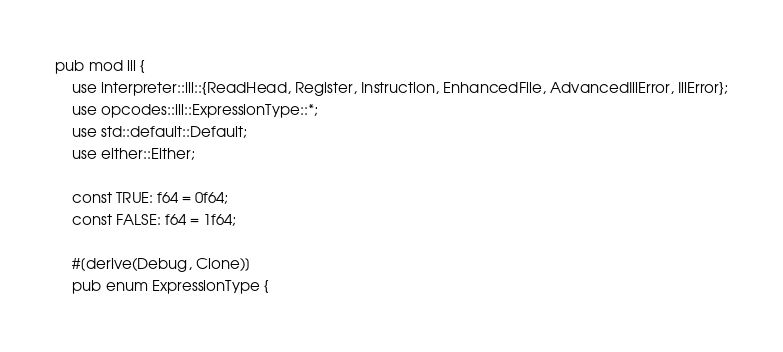<code> <loc_0><loc_0><loc_500><loc_500><_Rust_>pub mod ill {
    use interpreter::ill::{ReadHead, Register, Instruction, EnhancedFile, AdvancedIllError, IllError};
    use opcodes::ill::ExpressionType::*;
    use std::default::Default;
    use either::Either;

    const TRUE: f64 = 0f64;
    const FALSE: f64 = 1f64;

    #[derive(Debug, Clone)]
    pub enum ExpressionType {</code> 